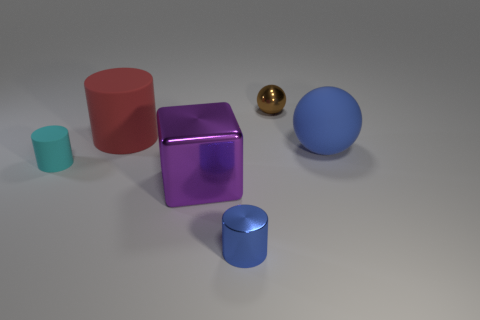Is there any other thing that is the same shape as the purple object?
Your response must be concise. No. There is a tiny cylinder right of the small cylinder that is to the left of the red object; how many blue rubber spheres are on the left side of it?
Make the answer very short. 0. Is the shape of the small blue metal object the same as the brown metal object?
Make the answer very short. No. Is the large object that is right of the brown metallic ball made of the same material as the blue object left of the small brown ball?
Offer a terse response. No. How many things are rubber cylinders that are to the right of the cyan matte thing or things on the left side of the large sphere?
Your response must be concise. 5. What number of metallic spheres are there?
Offer a very short reply. 1. Are there any brown metal objects that have the same size as the blue metal cylinder?
Offer a terse response. Yes. Are the big red cylinder and the sphere in front of the small ball made of the same material?
Your answer should be compact. Yes. There is a big thing that is on the left side of the purple metallic object; what is it made of?
Your response must be concise. Rubber. The block is what size?
Your answer should be very brief. Large. 